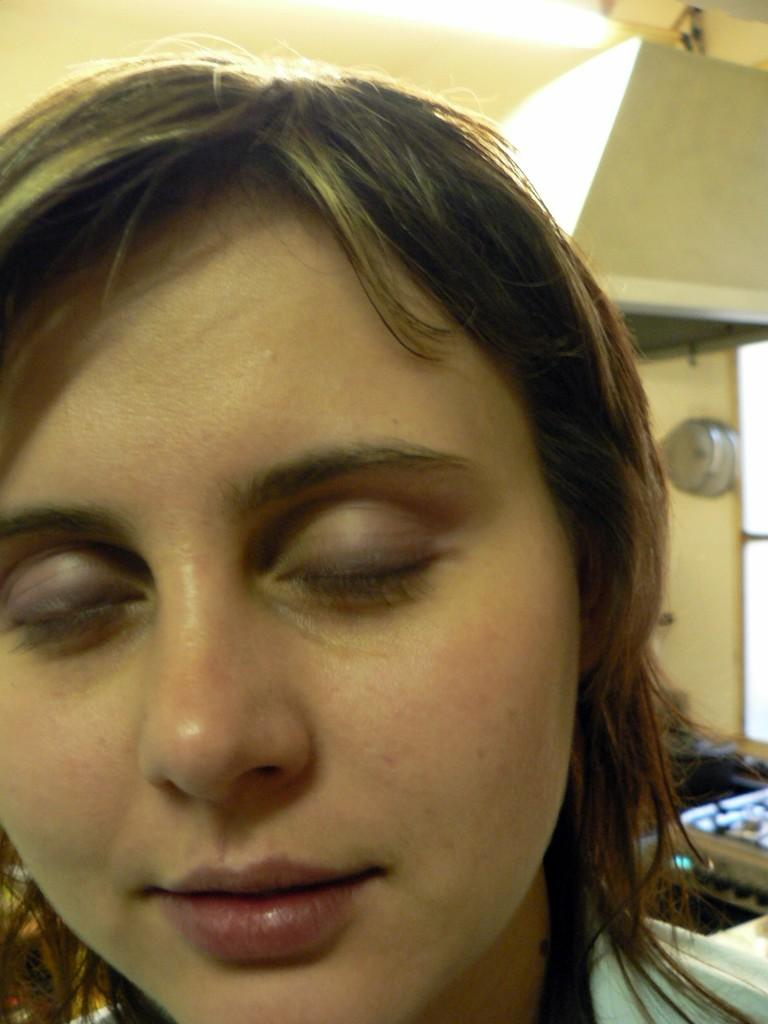What is the main focus of the image? There is a close-up view of a woman's face in the image. What is the woman doing in the image? The woman has closed her eyes and is smiling. Can you describe the background of the image? The background of the image is unclear or blurry. How many eggs can be seen in the woman's hair in the image? There are no eggs present in the image, as it is a close-up view of a woman's face. What type of coil is wrapped around the woman's neck in the image? There is no coil or any other object wrapped around the woman's neck in the image. 